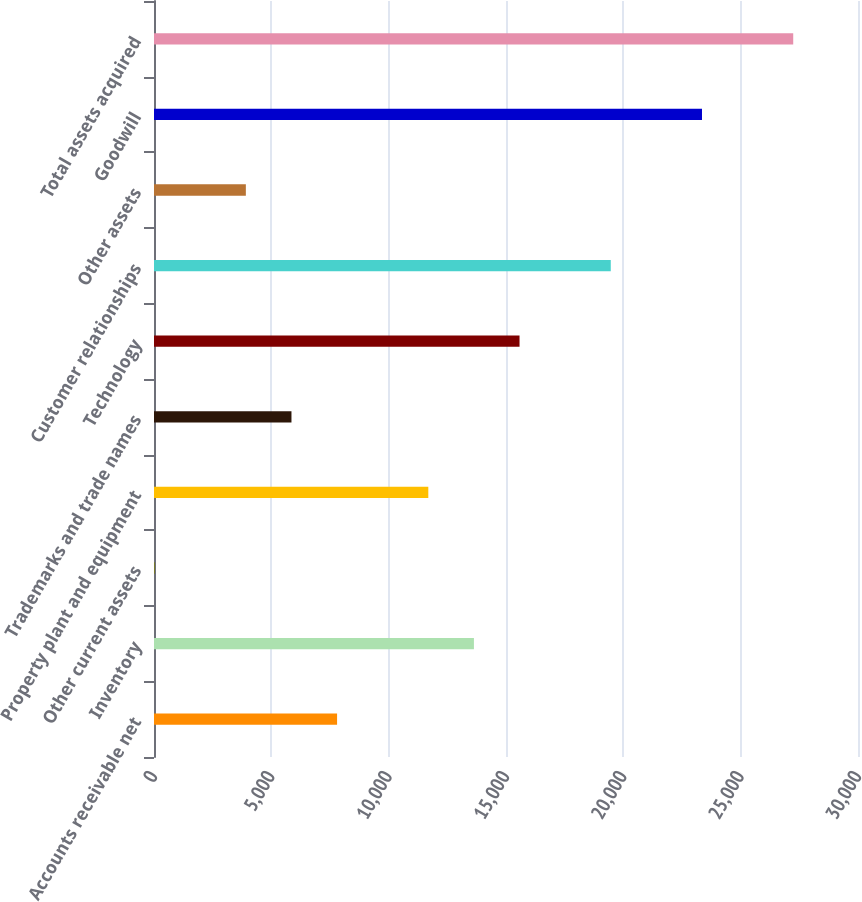Convert chart. <chart><loc_0><loc_0><loc_500><loc_500><bar_chart><fcel>Accounts receivable net<fcel>Inventory<fcel>Other current assets<fcel>Property plant and equipment<fcel>Trademarks and trade names<fcel>Technology<fcel>Customer relationships<fcel>Other assets<fcel>Goodwill<fcel>Total assets acquired<nl><fcel>7801.6<fcel>13633<fcel>26.4<fcel>11689.2<fcel>5857.8<fcel>15576.8<fcel>19464.4<fcel>3914<fcel>23352<fcel>27239.6<nl></chart> 